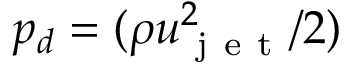Convert formula to latex. <formula><loc_0><loc_0><loc_500><loc_500>p _ { d } = ( \rho u _ { j e t } ^ { 2 } / 2 )</formula> 